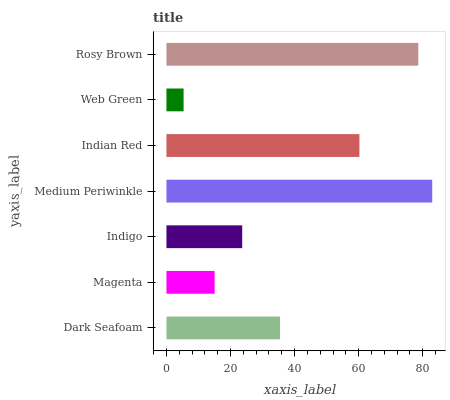Is Web Green the minimum?
Answer yes or no. Yes. Is Medium Periwinkle the maximum?
Answer yes or no. Yes. Is Magenta the minimum?
Answer yes or no. No. Is Magenta the maximum?
Answer yes or no. No. Is Dark Seafoam greater than Magenta?
Answer yes or no. Yes. Is Magenta less than Dark Seafoam?
Answer yes or no. Yes. Is Magenta greater than Dark Seafoam?
Answer yes or no. No. Is Dark Seafoam less than Magenta?
Answer yes or no. No. Is Dark Seafoam the high median?
Answer yes or no. Yes. Is Dark Seafoam the low median?
Answer yes or no. Yes. Is Indian Red the high median?
Answer yes or no. No. Is Rosy Brown the low median?
Answer yes or no. No. 